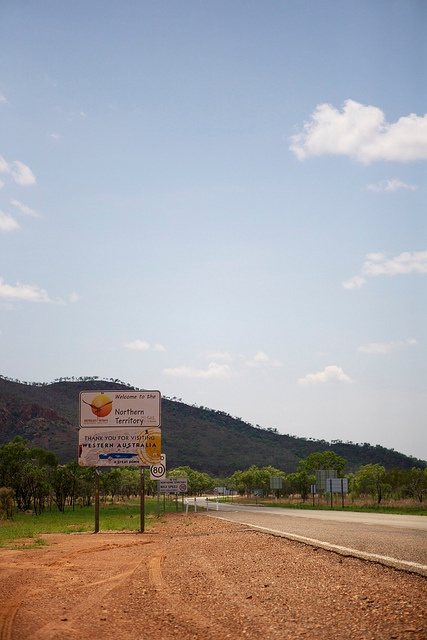Describe the objects in this image and their specific colors. I can see various objects in this image with different colors. 